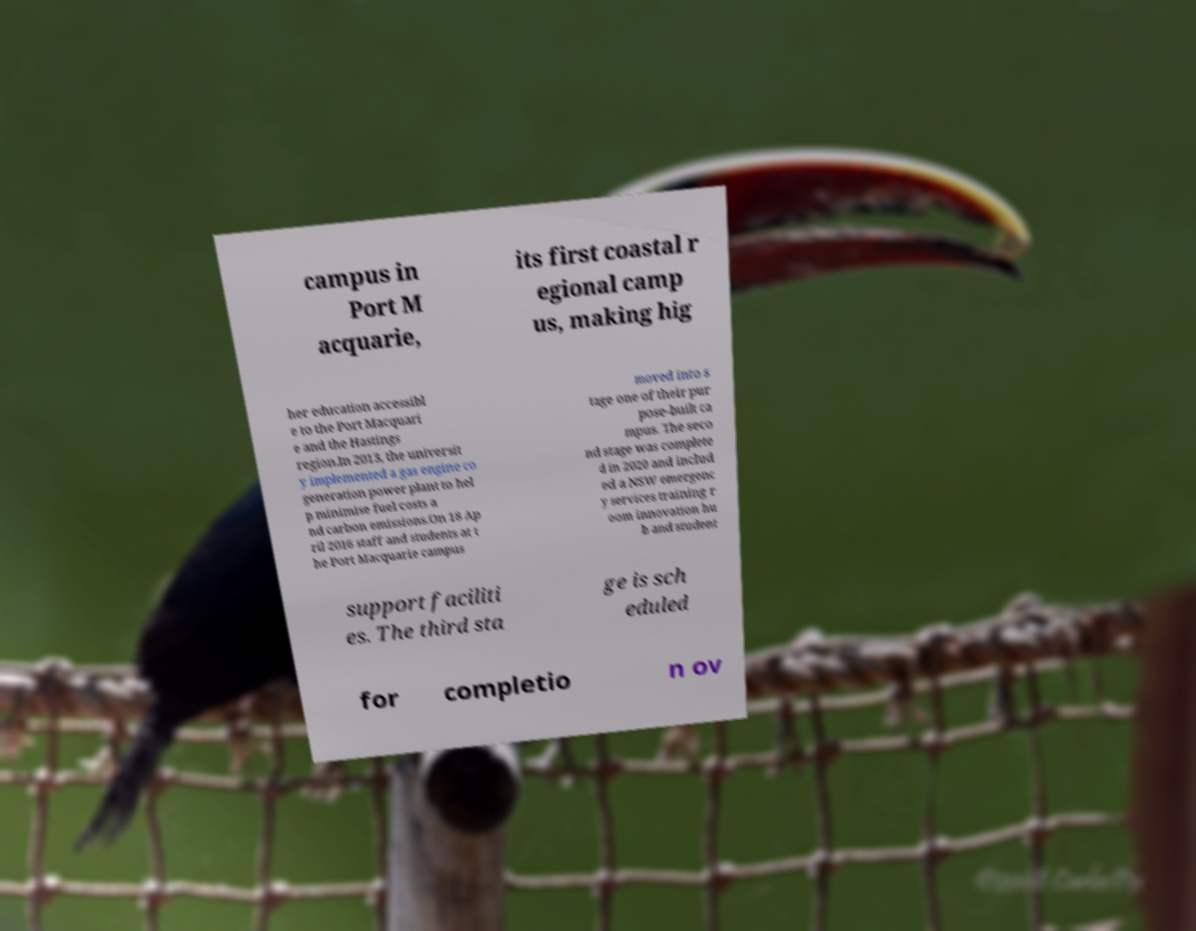Could you extract and type out the text from this image? campus in Port M acquarie, its first coastal r egional camp us, making hig her education accessibl e to the Port Macquari e and the Hastings region.In 2013, the universit y implemented a gas engine co generation power plant to hel p minimise fuel costs a nd carbon emissions.On 18 Ap ril 2016 staff and students at t he Port Macquarie campus moved into s tage one of their pur pose-built ca mpus. The seco nd stage was complete d in 2020 and includ ed a NSW emergenc y services training r oom innovation hu b and student support faciliti es. The third sta ge is sch eduled for completio n ov 